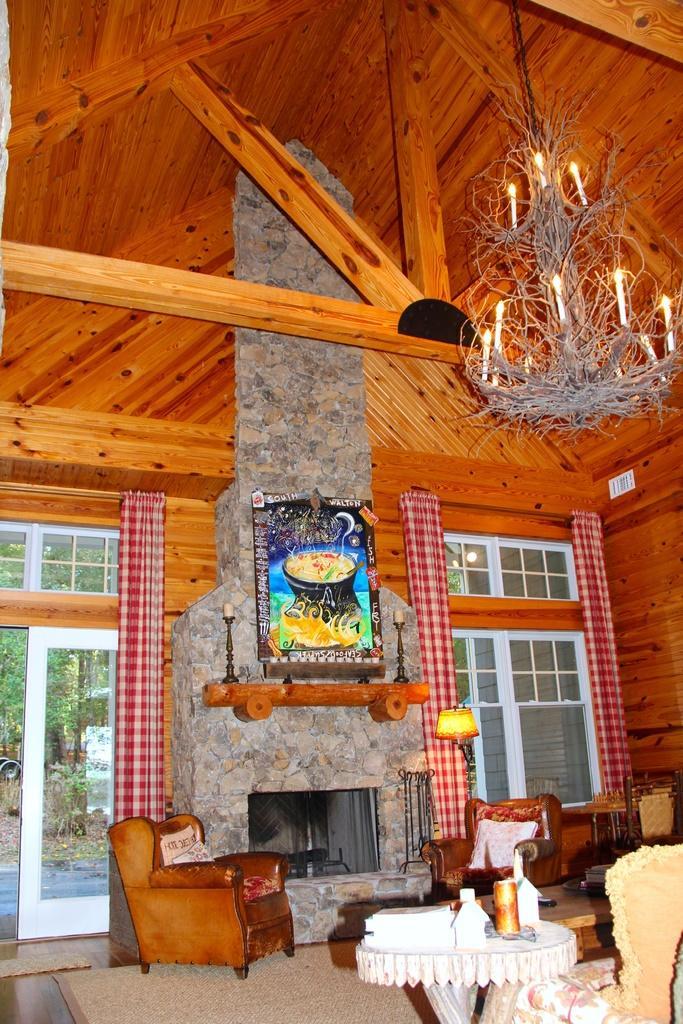In one or two sentences, can you explain what this image depicts? In this image i can see a bottle on the table, two chairs,two couches. At the back ground i can see a television,a wooden pole, a frame attached to a wall,a curtain ,a door, a window, a tree and at the top i can see a chandelier. 